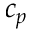Convert formula to latex. <formula><loc_0><loc_0><loc_500><loc_500>c _ { p }</formula> 